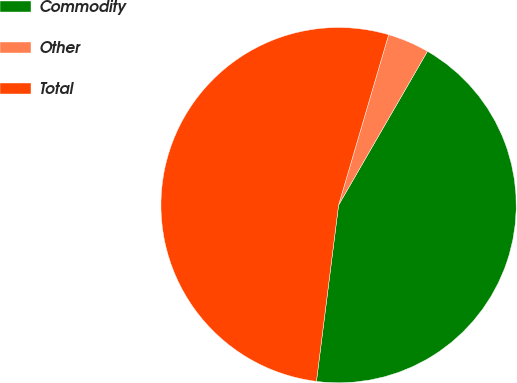<chart> <loc_0><loc_0><loc_500><loc_500><pie_chart><fcel>Commodity<fcel>Other<fcel>Total<nl><fcel>43.65%<fcel>3.79%<fcel>52.56%<nl></chart> 